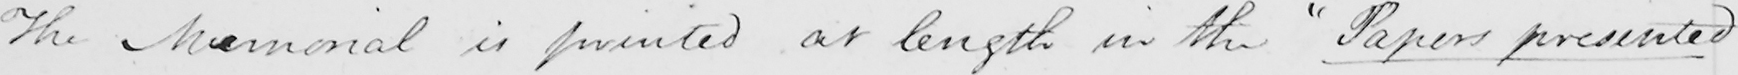Please transcribe the handwritten text in this image. The Memorial is printed at length in the  " Papers presented 